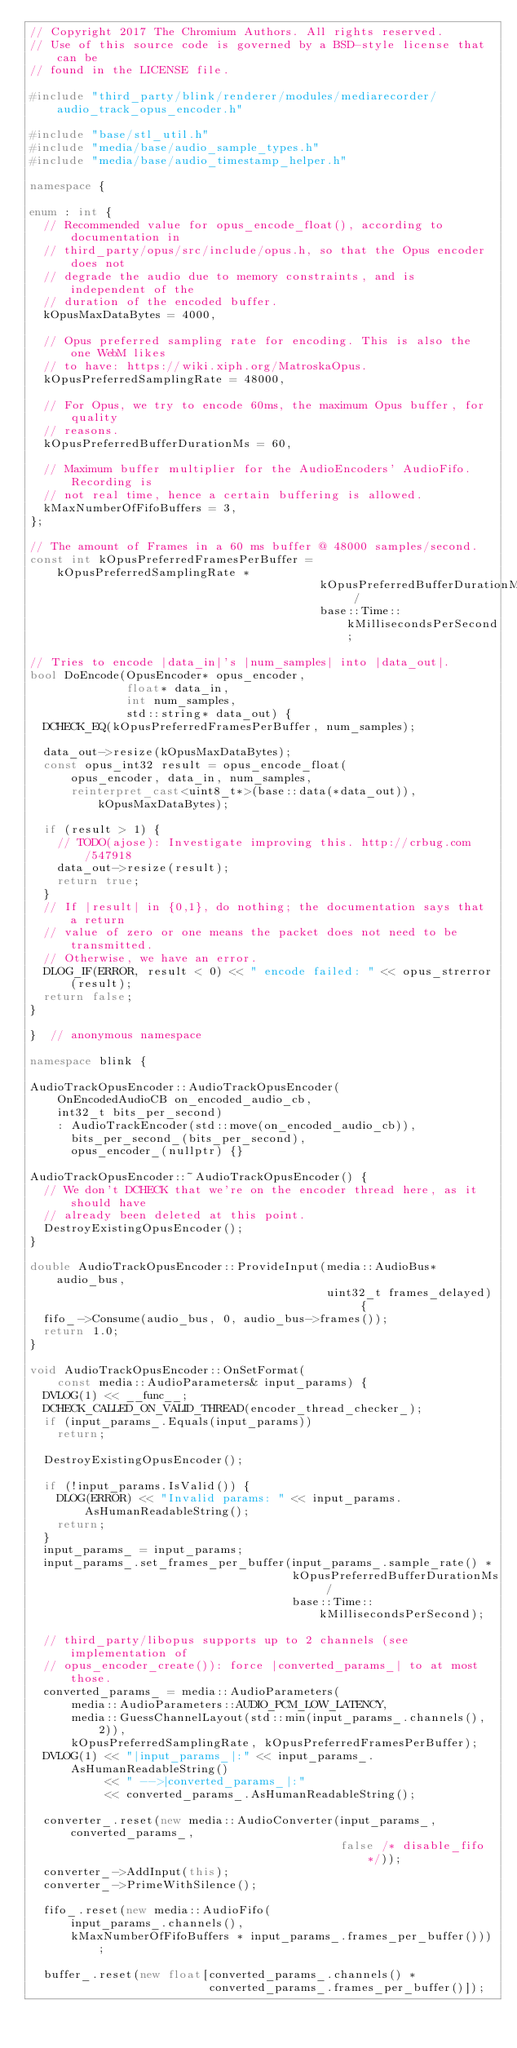<code> <loc_0><loc_0><loc_500><loc_500><_C++_>// Copyright 2017 The Chromium Authors. All rights reserved.
// Use of this source code is governed by a BSD-style license that can be
// found in the LICENSE file.

#include "third_party/blink/renderer/modules/mediarecorder/audio_track_opus_encoder.h"

#include "base/stl_util.h"
#include "media/base/audio_sample_types.h"
#include "media/base/audio_timestamp_helper.h"

namespace {

enum : int {
  // Recommended value for opus_encode_float(), according to documentation in
  // third_party/opus/src/include/opus.h, so that the Opus encoder does not
  // degrade the audio due to memory constraints, and is independent of the
  // duration of the encoded buffer.
  kOpusMaxDataBytes = 4000,

  // Opus preferred sampling rate for encoding. This is also the one WebM likes
  // to have: https://wiki.xiph.org/MatroskaOpus.
  kOpusPreferredSamplingRate = 48000,

  // For Opus, we try to encode 60ms, the maximum Opus buffer, for quality
  // reasons.
  kOpusPreferredBufferDurationMs = 60,

  // Maximum buffer multiplier for the AudioEncoders' AudioFifo. Recording is
  // not real time, hence a certain buffering is allowed.
  kMaxNumberOfFifoBuffers = 3,
};

// The amount of Frames in a 60 ms buffer @ 48000 samples/second.
const int kOpusPreferredFramesPerBuffer = kOpusPreferredSamplingRate *
                                          kOpusPreferredBufferDurationMs /
                                          base::Time::kMillisecondsPerSecond;

// Tries to encode |data_in|'s |num_samples| into |data_out|.
bool DoEncode(OpusEncoder* opus_encoder,
              float* data_in,
              int num_samples,
              std::string* data_out) {
  DCHECK_EQ(kOpusPreferredFramesPerBuffer, num_samples);

  data_out->resize(kOpusMaxDataBytes);
  const opus_int32 result = opus_encode_float(
      opus_encoder, data_in, num_samples,
      reinterpret_cast<uint8_t*>(base::data(*data_out)), kOpusMaxDataBytes);

  if (result > 1) {
    // TODO(ajose): Investigate improving this. http://crbug.com/547918
    data_out->resize(result);
    return true;
  }
  // If |result| in {0,1}, do nothing; the documentation says that a return
  // value of zero or one means the packet does not need to be transmitted.
  // Otherwise, we have an error.
  DLOG_IF(ERROR, result < 0) << " encode failed: " << opus_strerror(result);
  return false;
}

}  // anonymous namespace

namespace blink {

AudioTrackOpusEncoder::AudioTrackOpusEncoder(
    OnEncodedAudioCB on_encoded_audio_cb,
    int32_t bits_per_second)
    : AudioTrackEncoder(std::move(on_encoded_audio_cb)),
      bits_per_second_(bits_per_second),
      opus_encoder_(nullptr) {}

AudioTrackOpusEncoder::~AudioTrackOpusEncoder() {
  // We don't DCHECK that we're on the encoder thread here, as it should have
  // already been deleted at this point.
  DestroyExistingOpusEncoder();
}

double AudioTrackOpusEncoder::ProvideInput(media::AudioBus* audio_bus,
                                           uint32_t frames_delayed) {
  fifo_->Consume(audio_bus, 0, audio_bus->frames());
  return 1.0;
}

void AudioTrackOpusEncoder::OnSetFormat(
    const media::AudioParameters& input_params) {
  DVLOG(1) << __func__;
  DCHECK_CALLED_ON_VALID_THREAD(encoder_thread_checker_);
  if (input_params_.Equals(input_params))
    return;

  DestroyExistingOpusEncoder();

  if (!input_params.IsValid()) {
    DLOG(ERROR) << "Invalid params: " << input_params.AsHumanReadableString();
    return;
  }
  input_params_ = input_params;
  input_params_.set_frames_per_buffer(input_params_.sample_rate() *
                                      kOpusPreferredBufferDurationMs /
                                      base::Time::kMillisecondsPerSecond);

  // third_party/libopus supports up to 2 channels (see implementation of
  // opus_encoder_create()): force |converted_params_| to at most those.
  converted_params_ = media::AudioParameters(
      media::AudioParameters::AUDIO_PCM_LOW_LATENCY,
      media::GuessChannelLayout(std::min(input_params_.channels(), 2)),
      kOpusPreferredSamplingRate, kOpusPreferredFramesPerBuffer);
  DVLOG(1) << "|input_params_|:" << input_params_.AsHumanReadableString()
           << " -->|converted_params_|:"
           << converted_params_.AsHumanReadableString();

  converter_.reset(new media::AudioConverter(input_params_, converted_params_,
                                             false /* disable_fifo */));
  converter_->AddInput(this);
  converter_->PrimeWithSilence();

  fifo_.reset(new media::AudioFifo(
      input_params_.channels(),
      kMaxNumberOfFifoBuffers * input_params_.frames_per_buffer()));

  buffer_.reset(new float[converted_params_.channels() *
                          converted_params_.frames_per_buffer()]);
</code> 